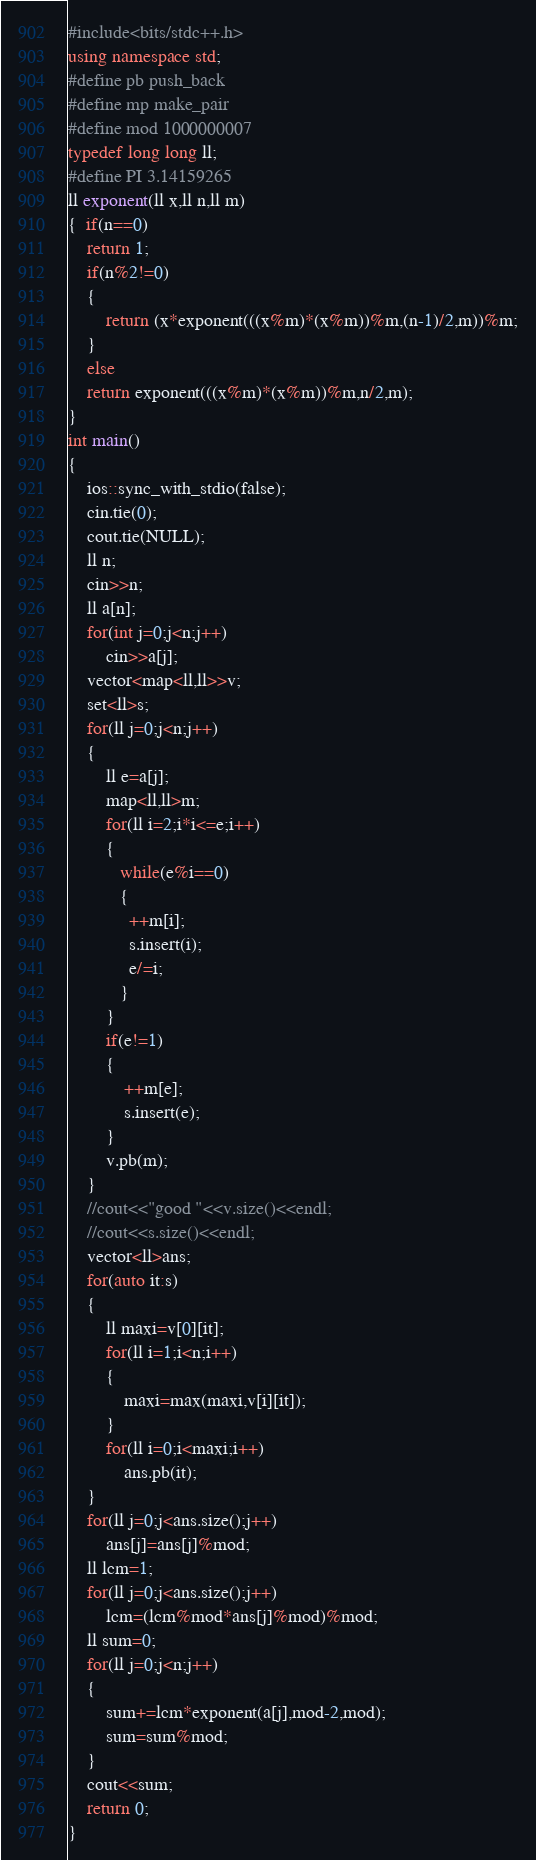Convert code to text. <code><loc_0><loc_0><loc_500><loc_500><_C++_>#include<bits/stdc++.h>
using namespace std;
#define pb push_back
#define mp make_pair
#define mod 1000000007
typedef long long ll;
#define PI 3.14159265
ll exponent(ll x,ll n,ll m)
{  if(n==0)
    return 1;
    if(n%2!=0)
    {
        return (x*exponent(((x%m)*(x%m))%m,(n-1)/2,m))%m;
    }
    else
    return exponent(((x%m)*(x%m))%m,n/2,m);
}
int main()
{
    ios::sync_with_stdio(false);
    cin.tie(0);
    cout.tie(NULL);
    ll n;
    cin>>n;
    ll a[n];
    for(int j=0;j<n;j++)
        cin>>a[j];
    vector<map<ll,ll>>v;
    set<ll>s;
    for(ll j=0;j<n;j++)
    {
        ll e=a[j];
        map<ll,ll>m;
        for(ll i=2;i*i<=e;i++)
        {
           while(e%i==0)
           {
             ++m[i];
             s.insert(i);
             e/=i;
           }
        }
        if(e!=1)
        {
            ++m[e];
            s.insert(e);
        }
        v.pb(m);
    }
    //cout<<"good "<<v.size()<<endl;
    //cout<<s.size()<<endl;
    vector<ll>ans;
    for(auto it:s)
    {
        ll maxi=v[0][it];
        for(ll i=1;i<n;i++)
        {
            maxi=max(maxi,v[i][it]);
        }
        for(ll i=0;i<maxi;i++)
            ans.pb(it);
    }
    for(ll j=0;j<ans.size();j++)
        ans[j]=ans[j]%mod;
    ll lcm=1;
    for(ll j=0;j<ans.size();j++)
        lcm=(lcm%mod*ans[j]%mod)%mod;
    ll sum=0;
    for(ll j=0;j<n;j++)
    {
        sum+=lcm*exponent(a[j],mod-2,mod);
        sum=sum%mod;
    }
    cout<<sum;
    return 0;
}
</code> 